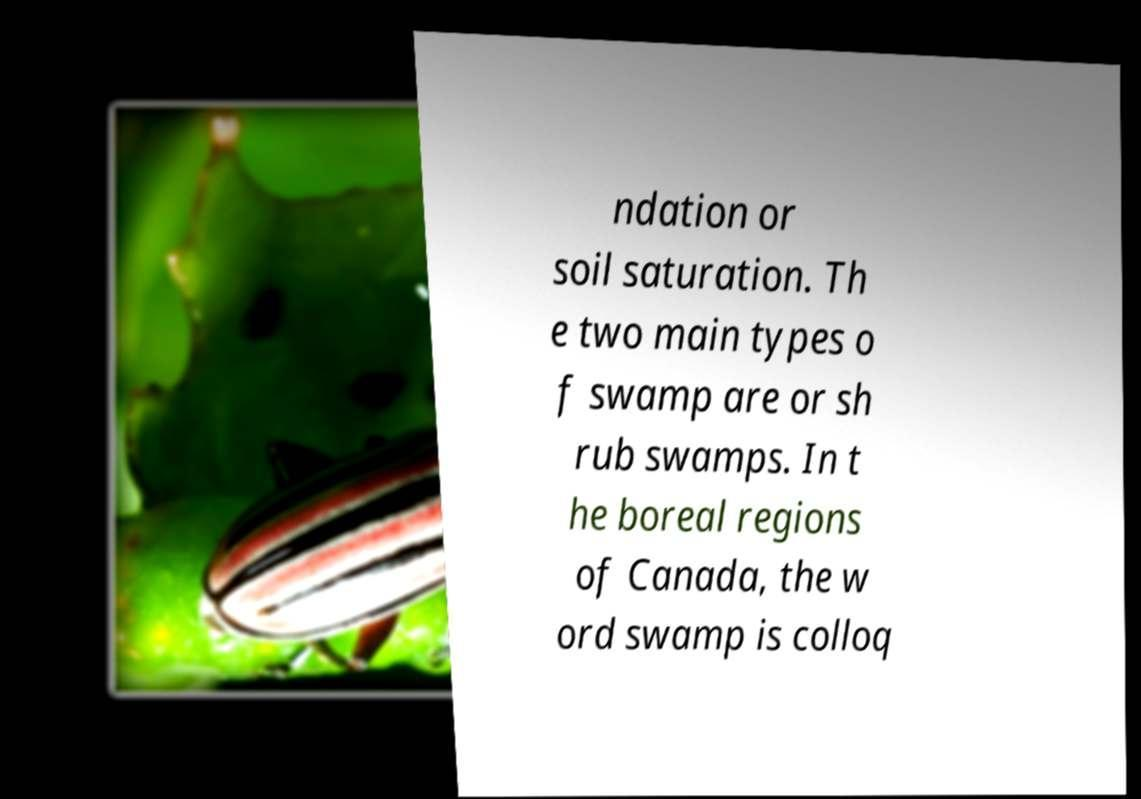There's text embedded in this image that I need extracted. Can you transcribe it verbatim? ndation or soil saturation. Th e two main types o f swamp are or sh rub swamps. In t he boreal regions of Canada, the w ord swamp is colloq 